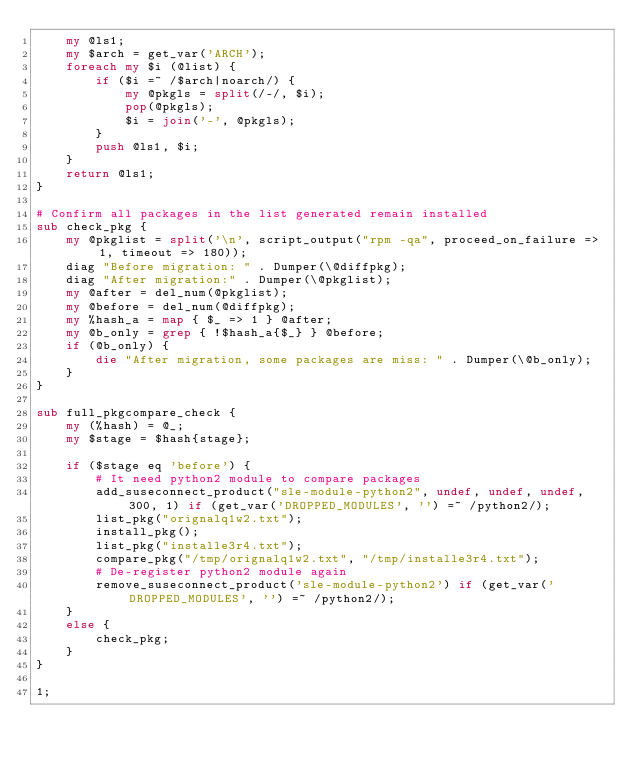<code> <loc_0><loc_0><loc_500><loc_500><_Perl_>    my @ls1;
    my $arch = get_var('ARCH');
    foreach my $i (@list) {
        if ($i =~ /$arch|noarch/) {
            my @pkgls = split(/-/, $i);
            pop(@pkgls);
            $i = join('-', @pkgls);
        }
        push @ls1, $i;
    }
    return @ls1;
}

# Confirm all packages in the list generated remain installed
sub check_pkg {
    my @pkglist = split('\n', script_output("rpm -qa", proceed_on_failure => 1, timeout => 180));
    diag "Before migration: " . Dumper(\@diffpkg);
    diag "After migration:" . Dumper(\@pkglist);
    my @after = del_num(@pkglist);
    my @before = del_num(@diffpkg);
    my %hash_a = map { $_ => 1 } @after;
    my @b_only = grep { !$hash_a{$_} } @before;
    if (@b_only) {
        die "After migration, some packages are miss: " . Dumper(\@b_only);
    }
}

sub full_pkgcompare_check {
    my (%hash) = @_;
    my $stage = $hash{stage};

    if ($stage eq 'before') {
        # It need python2 module to compare packages
        add_suseconnect_product("sle-module-python2", undef, undef, undef, 300, 1) if (get_var('DROPPED_MODULES', '') =~ /python2/);
        list_pkg("orignalq1w2.txt");
        install_pkg();
        list_pkg("installe3r4.txt");
        compare_pkg("/tmp/orignalq1w2.txt", "/tmp/installe3r4.txt");
        # De-register python2 module again
        remove_suseconnect_product('sle-module-python2') if (get_var('DROPPED_MODULES', '') =~ /python2/);
    }
    else {
        check_pkg;
    }
}

1;
</code> 